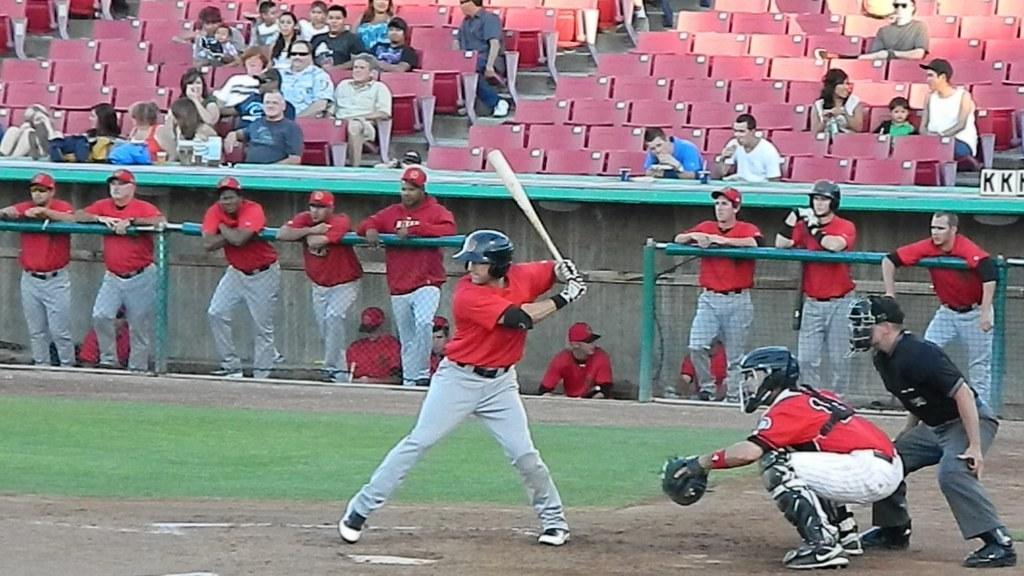<image>
Provide a brief description of the given image. The letters KK behind a baseball player waiting to play. 